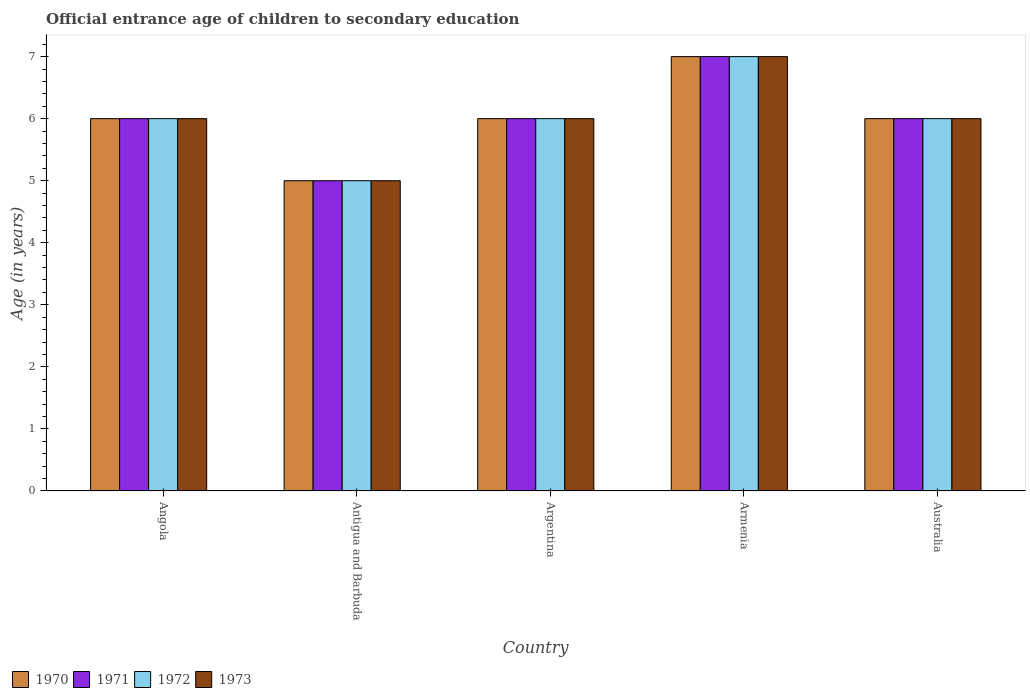How many different coloured bars are there?
Ensure brevity in your answer.  4. How many bars are there on the 5th tick from the left?
Make the answer very short. 4. How many bars are there on the 4th tick from the right?
Your answer should be very brief. 4. What is the label of the 5th group of bars from the left?
Keep it short and to the point. Australia. In how many cases, is the number of bars for a given country not equal to the number of legend labels?
Offer a terse response. 0. What is the secondary school starting age of children in 1973 in Angola?
Provide a short and direct response. 6. Across all countries, what is the maximum secondary school starting age of children in 1971?
Provide a short and direct response. 7. In which country was the secondary school starting age of children in 1970 maximum?
Offer a very short reply. Armenia. In which country was the secondary school starting age of children in 1971 minimum?
Ensure brevity in your answer.  Antigua and Barbuda. What is the difference between the secondary school starting age of children in 1970 in Antigua and Barbuda and the secondary school starting age of children in 1972 in Armenia?
Your answer should be compact. -2. What is the difference between the secondary school starting age of children of/in 1972 and secondary school starting age of children of/in 1973 in Argentina?
Ensure brevity in your answer.  0. In how many countries, is the secondary school starting age of children in 1970 greater than 2.2 years?
Your answer should be very brief. 5. What is the ratio of the secondary school starting age of children in 1972 in Argentina to that in Armenia?
Provide a succinct answer. 0.86. Is the secondary school starting age of children in 1971 in Angola less than that in Antigua and Barbuda?
Offer a very short reply. No. What is the difference between the highest and the second highest secondary school starting age of children in 1973?
Give a very brief answer. -1. Is it the case that in every country, the sum of the secondary school starting age of children in 1971 and secondary school starting age of children in 1972 is greater than the sum of secondary school starting age of children in 1970 and secondary school starting age of children in 1973?
Offer a terse response. No. What does the 3rd bar from the left in Argentina represents?
Make the answer very short. 1972. What does the 1st bar from the right in Australia represents?
Your response must be concise. 1973. Is it the case that in every country, the sum of the secondary school starting age of children in 1973 and secondary school starting age of children in 1970 is greater than the secondary school starting age of children in 1972?
Provide a succinct answer. Yes. How many bars are there?
Offer a very short reply. 20. Are all the bars in the graph horizontal?
Give a very brief answer. No. What is the difference between two consecutive major ticks on the Y-axis?
Offer a terse response. 1. Are the values on the major ticks of Y-axis written in scientific E-notation?
Your answer should be very brief. No. Does the graph contain any zero values?
Keep it short and to the point. No. Does the graph contain grids?
Give a very brief answer. No. Where does the legend appear in the graph?
Give a very brief answer. Bottom left. How many legend labels are there?
Provide a succinct answer. 4. How are the legend labels stacked?
Provide a short and direct response. Horizontal. What is the title of the graph?
Ensure brevity in your answer.  Official entrance age of children to secondary education. What is the label or title of the X-axis?
Your answer should be compact. Country. What is the label or title of the Y-axis?
Provide a succinct answer. Age (in years). What is the Age (in years) in 1970 in Angola?
Make the answer very short. 6. What is the Age (in years) of 1971 in Angola?
Give a very brief answer. 6. What is the Age (in years) in 1972 in Angola?
Offer a terse response. 6. What is the Age (in years) in 1970 in Antigua and Barbuda?
Ensure brevity in your answer.  5. What is the Age (in years) of 1971 in Antigua and Barbuda?
Give a very brief answer. 5. What is the Age (in years) of 1970 in Argentina?
Make the answer very short. 6. What is the Age (in years) of 1971 in Argentina?
Give a very brief answer. 6. What is the Age (in years) of 1973 in Argentina?
Provide a short and direct response. 6. What is the Age (in years) in 1971 in Armenia?
Provide a short and direct response. 7. What is the Age (in years) of 1972 in Armenia?
Offer a terse response. 7. What is the Age (in years) of 1973 in Armenia?
Provide a succinct answer. 7. What is the Age (in years) of 1970 in Australia?
Give a very brief answer. 6. What is the Age (in years) in 1971 in Australia?
Provide a short and direct response. 6. What is the Age (in years) of 1972 in Australia?
Give a very brief answer. 6. What is the Age (in years) in 1973 in Australia?
Offer a very short reply. 6. Across all countries, what is the maximum Age (in years) in 1971?
Provide a short and direct response. 7. Across all countries, what is the maximum Age (in years) of 1972?
Your answer should be very brief. 7. Across all countries, what is the maximum Age (in years) of 1973?
Offer a very short reply. 7. Across all countries, what is the minimum Age (in years) in 1972?
Your response must be concise. 5. Across all countries, what is the minimum Age (in years) of 1973?
Provide a succinct answer. 5. What is the total Age (in years) of 1970 in the graph?
Keep it short and to the point. 30. What is the total Age (in years) of 1973 in the graph?
Offer a terse response. 30. What is the difference between the Age (in years) in 1970 in Angola and that in Antigua and Barbuda?
Your response must be concise. 1. What is the difference between the Age (in years) of 1972 in Angola and that in Antigua and Barbuda?
Your response must be concise. 1. What is the difference between the Age (in years) of 1970 in Angola and that in Argentina?
Your answer should be compact. 0. What is the difference between the Age (in years) of 1972 in Angola and that in Argentina?
Offer a very short reply. 0. What is the difference between the Age (in years) of 1973 in Angola and that in Argentina?
Give a very brief answer. 0. What is the difference between the Age (in years) of 1971 in Angola and that in Armenia?
Keep it short and to the point. -1. What is the difference between the Age (in years) in 1972 in Angola and that in Armenia?
Your response must be concise. -1. What is the difference between the Age (in years) of 1973 in Angola and that in Armenia?
Give a very brief answer. -1. What is the difference between the Age (in years) of 1970 in Angola and that in Australia?
Offer a very short reply. 0. What is the difference between the Age (in years) of 1971 in Angola and that in Australia?
Make the answer very short. 0. What is the difference between the Age (in years) in 1973 in Angola and that in Australia?
Your answer should be very brief. 0. What is the difference between the Age (in years) in 1970 in Antigua and Barbuda and that in Argentina?
Your answer should be compact. -1. What is the difference between the Age (in years) in 1971 in Antigua and Barbuda and that in Argentina?
Provide a succinct answer. -1. What is the difference between the Age (in years) in 1972 in Antigua and Barbuda and that in Argentina?
Provide a short and direct response. -1. What is the difference between the Age (in years) of 1970 in Antigua and Barbuda and that in Armenia?
Provide a short and direct response. -2. What is the difference between the Age (in years) of 1971 in Antigua and Barbuda and that in Armenia?
Make the answer very short. -2. What is the difference between the Age (in years) of 1973 in Antigua and Barbuda and that in Armenia?
Make the answer very short. -2. What is the difference between the Age (in years) in 1970 in Antigua and Barbuda and that in Australia?
Keep it short and to the point. -1. What is the difference between the Age (in years) of 1972 in Antigua and Barbuda and that in Australia?
Provide a short and direct response. -1. What is the difference between the Age (in years) of 1973 in Antigua and Barbuda and that in Australia?
Keep it short and to the point. -1. What is the difference between the Age (in years) in 1970 in Argentina and that in Armenia?
Give a very brief answer. -1. What is the difference between the Age (in years) of 1971 in Argentina and that in Armenia?
Your answer should be compact. -1. What is the difference between the Age (in years) in 1972 in Argentina and that in Armenia?
Provide a succinct answer. -1. What is the difference between the Age (in years) of 1970 in Argentina and that in Australia?
Your answer should be very brief. 0. What is the difference between the Age (in years) of 1971 in Argentina and that in Australia?
Keep it short and to the point. 0. What is the difference between the Age (in years) of 1972 in Argentina and that in Australia?
Provide a succinct answer. 0. What is the difference between the Age (in years) of 1973 in Argentina and that in Australia?
Offer a very short reply. 0. What is the difference between the Age (in years) in 1970 in Armenia and that in Australia?
Offer a very short reply. 1. What is the difference between the Age (in years) in 1970 in Angola and the Age (in years) in 1971 in Antigua and Barbuda?
Ensure brevity in your answer.  1. What is the difference between the Age (in years) in 1970 in Angola and the Age (in years) in 1971 in Argentina?
Your answer should be compact. 0. What is the difference between the Age (in years) of 1970 in Angola and the Age (in years) of 1972 in Argentina?
Offer a very short reply. 0. What is the difference between the Age (in years) of 1971 in Angola and the Age (in years) of 1972 in Argentina?
Give a very brief answer. 0. What is the difference between the Age (in years) in 1971 in Angola and the Age (in years) in 1973 in Argentina?
Offer a terse response. 0. What is the difference between the Age (in years) of 1972 in Angola and the Age (in years) of 1973 in Argentina?
Your response must be concise. 0. What is the difference between the Age (in years) of 1970 in Angola and the Age (in years) of 1973 in Armenia?
Offer a very short reply. -1. What is the difference between the Age (in years) in 1971 in Angola and the Age (in years) in 1972 in Armenia?
Your answer should be very brief. -1. What is the difference between the Age (in years) in 1970 in Angola and the Age (in years) in 1971 in Australia?
Make the answer very short. 0. What is the difference between the Age (in years) in 1970 in Angola and the Age (in years) in 1973 in Australia?
Your answer should be very brief. 0. What is the difference between the Age (in years) in 1971 in Angola and the Age (in years) in 1973 in Australia?
Keep it short and to the point. 0. What is the difference between the Age (in years) of 1972 in Angola and the Age (in years) of 1973 in Australia?
Give a very brief answer. 0. What is the difference between the Age (in years) of 1971 in Antigua and Barbuda and the Age (in years) of 1972 in Argentina?
Provide a succinct answer. -1. What is the difference between the Age (in years) in 1971 in Antigua and Barbuda and the Age (in years) in 1973 in Argentina?
Offer a terse response. -1. What is the difference between the Age (in years) in 1972 in Antigua and Barbuda and the Age (in years) in 1973 in Argentina?
Keep it short and to the point. -1. What is the difference between the Age (in years) in 1970 in Antigua and Barbuda and the Age (in years) in 1971 in Armenia?
Ensure brevity in your answer.  -2. What is the difference between the Age (in years) in 1970 in Antigua and Barbuda and the Age (in years) in 1973 in Armenia?
Provide a short and direct response. -2. What is the difference between the Age (in years) in 1971 in Antigua and Barbuda and the Age (in years) in 1972 in Armenia?
Your answer should be very brief. -2. What is the difference between the Age (in years) of 1971 in Antigua and Barbuda and the Age (in years) of 1973 in Armenia?
Offer a terse response. -2. What is the difference between the Age (in years) of 1972 in Antigua and Barbuda and the Age (in years) of 1973 in Armenia?
Provide a succinct answer. -2. What is the difference between the Age (in years) of 1971 in Antigua and Barbuda and the Age (in years) of 1972 in Australia?
Your answer should be very brief. -1. What is the difference between the Age (in years) in 1971 in Antigua and Barbuda and the Age (in years) in 1973 in Australia?
Provide a succinct answer. -1. What is the difference between the Age (in years) of 1970 in Argentina and the Age (in years) of 1971 in Armenia?
Keep it short and to the point. -1. What is the difference between the Age (in years) of 1970 in Argentina and the Age (in years) of 1972 in Armenia?
Your answer should be very brief. -1. What is the difference between the Age (in years) of 1970 in Argentina and the Age (in years) of 1973 in Armenia?
Ensure brevity in your answer.  -1. What is the difference between the Age (in years) in 1971 in Argentina and the Age (in years) in 1972 in Armenia?
Your response must be concise. -1. What is the difference between the Age (in years) of 1971 in Argentina and the Age (in years) of 1973 in Armenia?
Offer a very short reply. -1. What is the difference between the Age (in years) in 1970 in Argentina and the Age (in years) in 1971 in Australia?
Give a very brief answer. 0. What is the difference between the Age (in years) in 1970 in Argentina and the Age (in years) in 1973 in Australia?
Make the answer very short. 0. What is the difference between the Age (in years) in 1971 in Argentina and the Age (in years) in 1972 in Australia?
Your response must be concise. 0. What is the difference between the Age (in years) of 1972 in Argentina and the Age (in years) of 1973 in Australia?
Give a very brief answer. 0. What is the difference between the Age (in years) in 1970 in Armenia and the Age (in years) in 1972 in Australia?
Provide a short and direct response. 1. What is the difference between the Age (in years) in 1971 in Armenia and the Age (in years) in 1972 in Australia?
Give a very brief answer. 1. What is the average Age (in years) of 1971 per country?
Provide a short and direct response. 6. What is the average Age (in years) in 1972 per country?
Provide a short and direct response. 6. What is the difference between the Age (in years) of 1970 and Age (in years) of 1971 in Angola?
Your response must be concise. 0. What is the difference between the Age (in years) of 1970 and Age (in years) of 1972 in Angola?
Provide a short and direct response. 0. What is the difference between the Age (in years) in 1971 and Age (in years) in 1973 in Angola?
Offer a terse response. 0. What is the difference between the Age (in years) in 1972 and Age (in years) in 1973 in Angola?
Your answer should be very brief. 0. What is the difference between the Age (in years) of 1970 and Age (in years) of 1971 in Antigua and Barbuda?
Your answer should be compact. 0. What is the difference between the Age (in years) in 1972 and Age (in years) in 1973 in Antigua and Barbuda?
Provide a succinct answer. 0. What is the difference between the Age (in years) of 1970 and Age (in years) of 1971 in Argentina?
Offer a terse response. 0. What is the difference between the Age (in years) in 1970 and Age (in years) in 1972 in Argentina?
Make the answer very short. 0. What is the difference between the Age (in years) in 1970 and Age (in years) in 1973 in Argentina?
Provide a short and direct response. 0. What is the difference between the Age (in years) of 1971 and Age (in years) of 1972 in Argentina?
Make the answer very short. 0. What is the difference between the Age (in years) in 1970 and Age (in years) in 1971 in Armenia?
Provide a short and direct response. 0. What is the difference between the Age (in years) of 1970 and Age (in years) of 1972 in Armenia?
Keep it short and to the point. 0. What is the difference between the Age (in years) of 1971 and Age (in years) of 1972 in Armenia?
Make the answer very short. 0. What is the difference between the Age (in years) in 1971 and Age (in years) in 1973 in Armenia?
Your response must be concise. 0. What is the difference between the Age (in years) of 1970 and Age (in years) of 1971 in Australia?
Give a very brief answer. 0. What is the difference between the Age (in years) of 1970 and Age (in years) of 1972 in Australia?
Your answer should be compact. 0. What is the difference between the Age (in years) in 1970 and Age (in years) in 1973 in Australia?
Make the answer very short. 0. What is the ratio of the Age (in years) of 1971 in Angola to that in Antigua and Barbuda?
Offer a terse response. 1.2. What is the ratio of the Age (in years) of 1973 in Angola to that in Antigua and Barbuda?
Make the answer very short. 1.2. What is the ratio of the Age (in years) in 1970 in Angola to that in Argentina?
Offer a terse response. 1. What is the ratio of the Age (in years) in 1971 in Angola to that in Argentina?
Your response must be concise. 1. What is the ratio of the Age (in years) of 1970 in Angola to that in Armenia?
Offer a very short reply. 0.86. What is the ratio of the Age (in years) of 1971 in Angola to that in Armenia?
Give a very brief answer. 0.86. What is the ratio of the Age (in years) of 1972 in Angola to that in Armenia?
Provide a short and direct response. 0.86. What is the ratio of the Age (in years) in 1970 in Angola to that in Australia?
Your answer should be compact. 1. What is the ratio of the Age (in years) of 1971 in Angola to that in Australia?
Offer a very short reply. 1. What is the ratio of the Age (in years) of 1973 in Angola to that in Australia?
Keep it short and to the point. 1. What is the ratio of the Age (in years) in 1970 in Antigua and Barbuda to that in Argentina?
Keep it short and to the point. 0.83. What is the ratio of the Age (in years) of 1972 in Antigua and Barbuda to that in Argentina?
Offer a very short reply. 0.83. What is the ratio of the Age (in years) in 1973 in Antigua and Barbuda to that in Argentina?
Give a very brief answer. 0.83. What is the ratio of the Age (in years) in 1970 in Antigua and Barbuda to that in Armenia?
Provide a succinct answer. 0.71. What is the ratio of the Age (in years) of 1971 in Antigua and Barbuda to that in Armenia?
Your answer should be very brief. 0.71. What is the ratio of the Age (in years) of 1970 in Antigua and Barbuda to that in Australia?
Your answer should be very brief. 0.83. What is the ratio of the Age (in years) in 1972 in Antigua and Barbuda to that in Australia?
Ensure brevity in your answer.  0.83. What is the ratio of the Age (in years) of 1973 in Antigua and Barbuda to that in Australia?
Your answer should be very brief. 0.83. What is the ratio of the Age (in years) in 1970 in Argentina to that in Armenia?
Your answer should be compact. 0.86. What is the ratio of the Age (in years) in 1973 in Argentina to that in Armenia?
Make the answer very short. 0.86. What is the ratio of the Age (in years) in 1970 in Argentina to that in Australia?
Provide a short and direct response. 1. What is the ratio of the Age (in years) in 1971 in Argentina to that in Australia?
Provide a short and direct response. 1. What is the ratio of the Age (in years) of 1973 in Argentina to that in Australia?
Offer a very short reply. 1. What is the ratio of the Age (in years) in 1970 in Armenia to that in Australia?
Provide a short and direct response. 1.17. What is the ratio of the Age (in years) of 1971 in Armenia to that in Australia?
Offer a terse response. 1.17. What is the ratio of the Age (in years) in 1972 in Armenia to that in Australia?
Offer a very short reply. 1.17. What is the difference between the highest and the second highest Age (in years) of 1970?
Make the answer very short. 1. What is the difference between the highest and the second highest Age (in years) in 1971?
Provide a succinct answer. 1. What is the difference between the highest and the second highest Age (in years) in 1972?
Your response must be concise. 1. What is the difference between the highest and the second highest Age (in years) of 1973?
Offer a terse response. 1. What is the difference between the highest and the lowest Age (in years) in 1970?
Provide a succinct answer. 2. What is the difference between the highest and the lowest Age (in years) of 1972?
Make the answer very short. 2. 